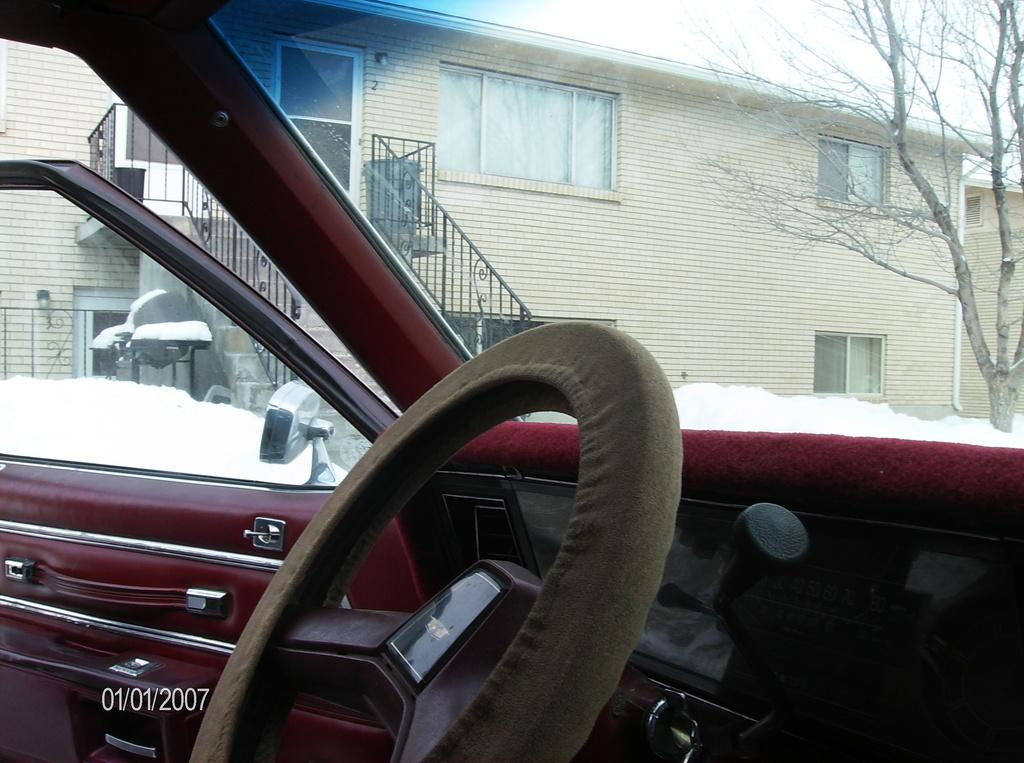What is the setting of the image? The image shows the inside of a car. What can be seen in the front of the car? The steering wheel is visible. Is there any text or logo in the image? Yes, there is a watermark in the left bottom of the image. What can be seen in the distance in the image? There are houses and a tree in the background of the image, and snow is visible. Where is the faucet located in the image? There is no faucet present in the image; it is a picture of the inside of a car. What are the hands of the driver doing in the image? The image does not show the driver's hands, as it is focused on the interior of the car. 